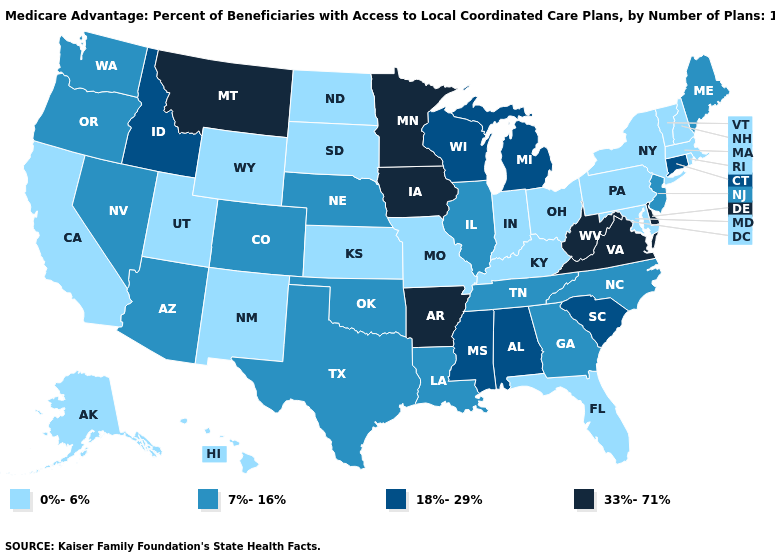What is the value of South Carolina?
Keep it brief. 18%-29%. Is the legend a continuous bar?
Give a very brief answer. No. What is the value of Oregon?
Concise answer only. 7%-16%. Among the states that border Maryland , does Pennsylvania have the lowest value?
Quick response, please. Yes. Which states hav the highest value in the West?
Be succinct. Montana. What is the value of Colorado?
Answer briefly. 7%-16%. Which states have the lowest value in the MidWest?
Concise answer only. Indiana, Kansas, Missouri, North Dakota, Ohio, South Dakota. Which states have the lowest value in the MidWest?
Short answer required. Indiana, Kansas, Missouri, North Dakota, Ohio, South Dakota. What is the value of North Carolina?
Short answer required. 7%-16%. Name the states that have a value in the range 0%-6%?
Answer briefly. Alaska, California, Florida, Hawaii, Indiana, Kansas, Kentucky, Massachusetts, Maryland, Missouri, North Dakota, New Hampshire, New Mexico, New York, Ohio, Pennsylvania, Rhode Island, South Dakota, Utah, Vermont, Wyoming. Name the states that have a value in the range 7%-16%?
Quick response, please. Arizona, Colorado, Georgia, Illinois, Louisiana, Maine, North Carolina, Nebraska, New Jersey, Nevada, Oklahoma, Oregon, Tennessee, Texas, Washington. What is the value of Georgia?
Give a very brief answer. 7%-16%. Name the states that have a value in the range 18%-29%?
Answer briefly. Alabama, Connecticut, Idaho, Michigan, Mississippi, South Carolina, Wisconsin. Does Missouri have the lowest value in the USA?
Write a very short answer. Yes. 